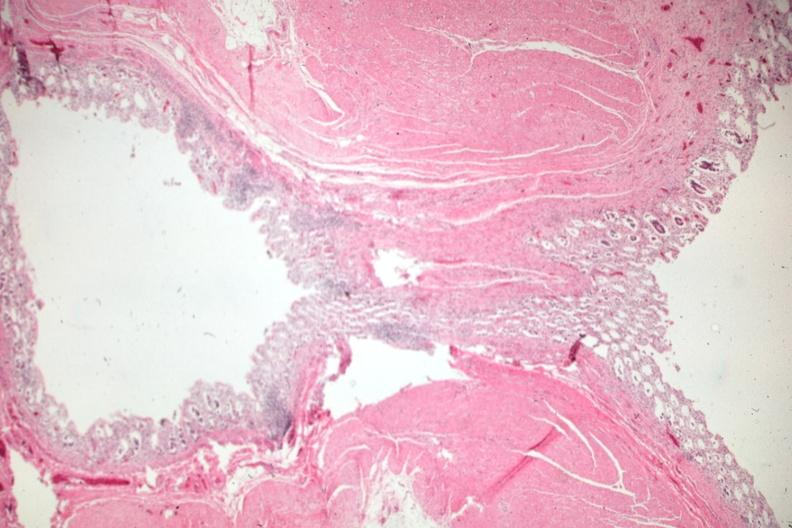where is this from?
Answer the question using a single word or phrase. Gastrointestinal system 